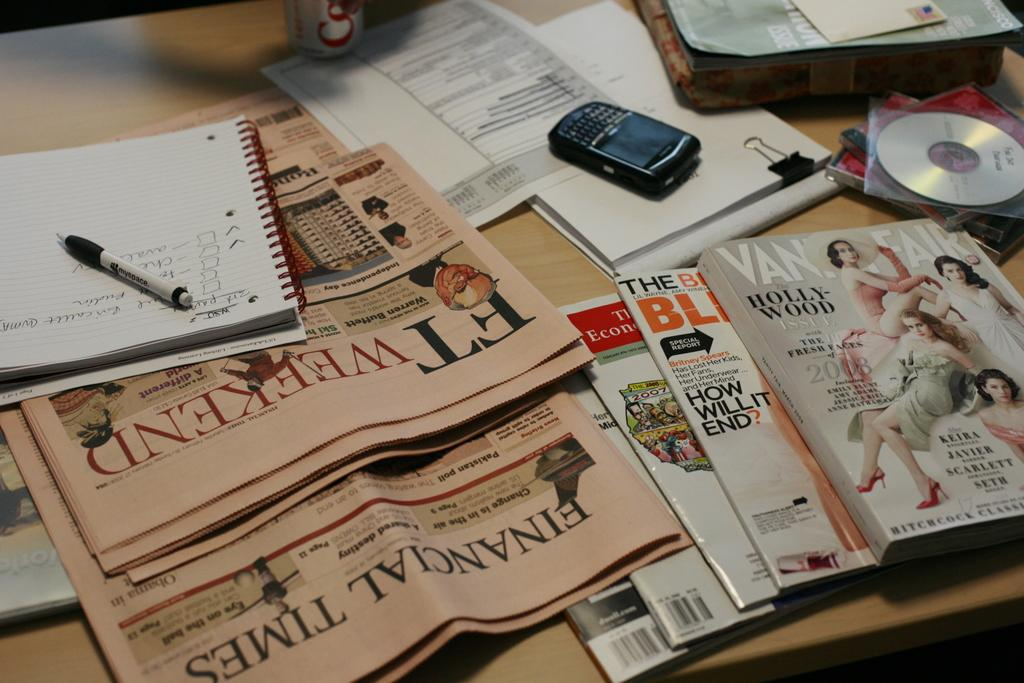<image>
Create a compact narrative representing the image presented. A table covered with newspapers and magazine including vanity fair 